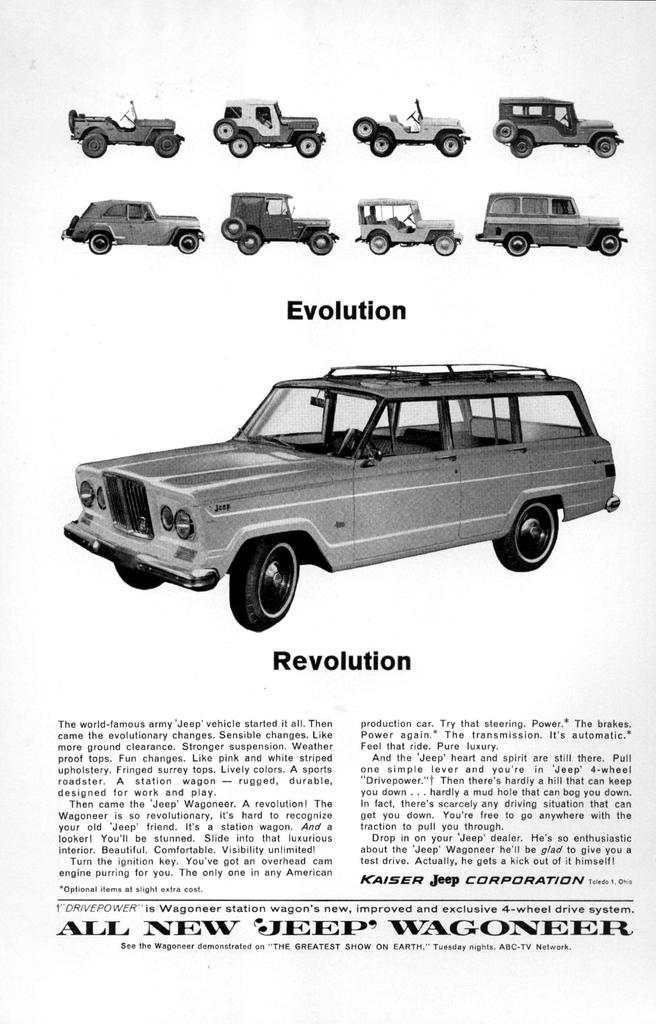What is the main subject of the image? The main subject of the image is an article. What else can be seen in the image besides the article? There are vehicles in the image. Is there any text present in the image? Yes, there is text written on the image. What type of mine is depicted in the image? There is no mine present in the image; it features an article and vehicles. How many cubs can be seen playing with the vehicles in the image? There are no cubs present in the image. 